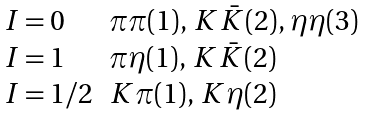Convert formula to latex. <formula><loc_0><loc_0><loc_500><loc_500>\begin{array} { l l } I = 0 & \pi \pi ( 1 ) , \, K \bar { K } ( 2 ) , \, \eta \eta ( 3 ) \\ I = 1 & \pi \eta ( 1 ) , \, K \bar { K } ( 2 ) \\ I = 1 / 2 & K \pi ( 1 ) , \, K \eta ( 2 ) \end{array}</formula> 